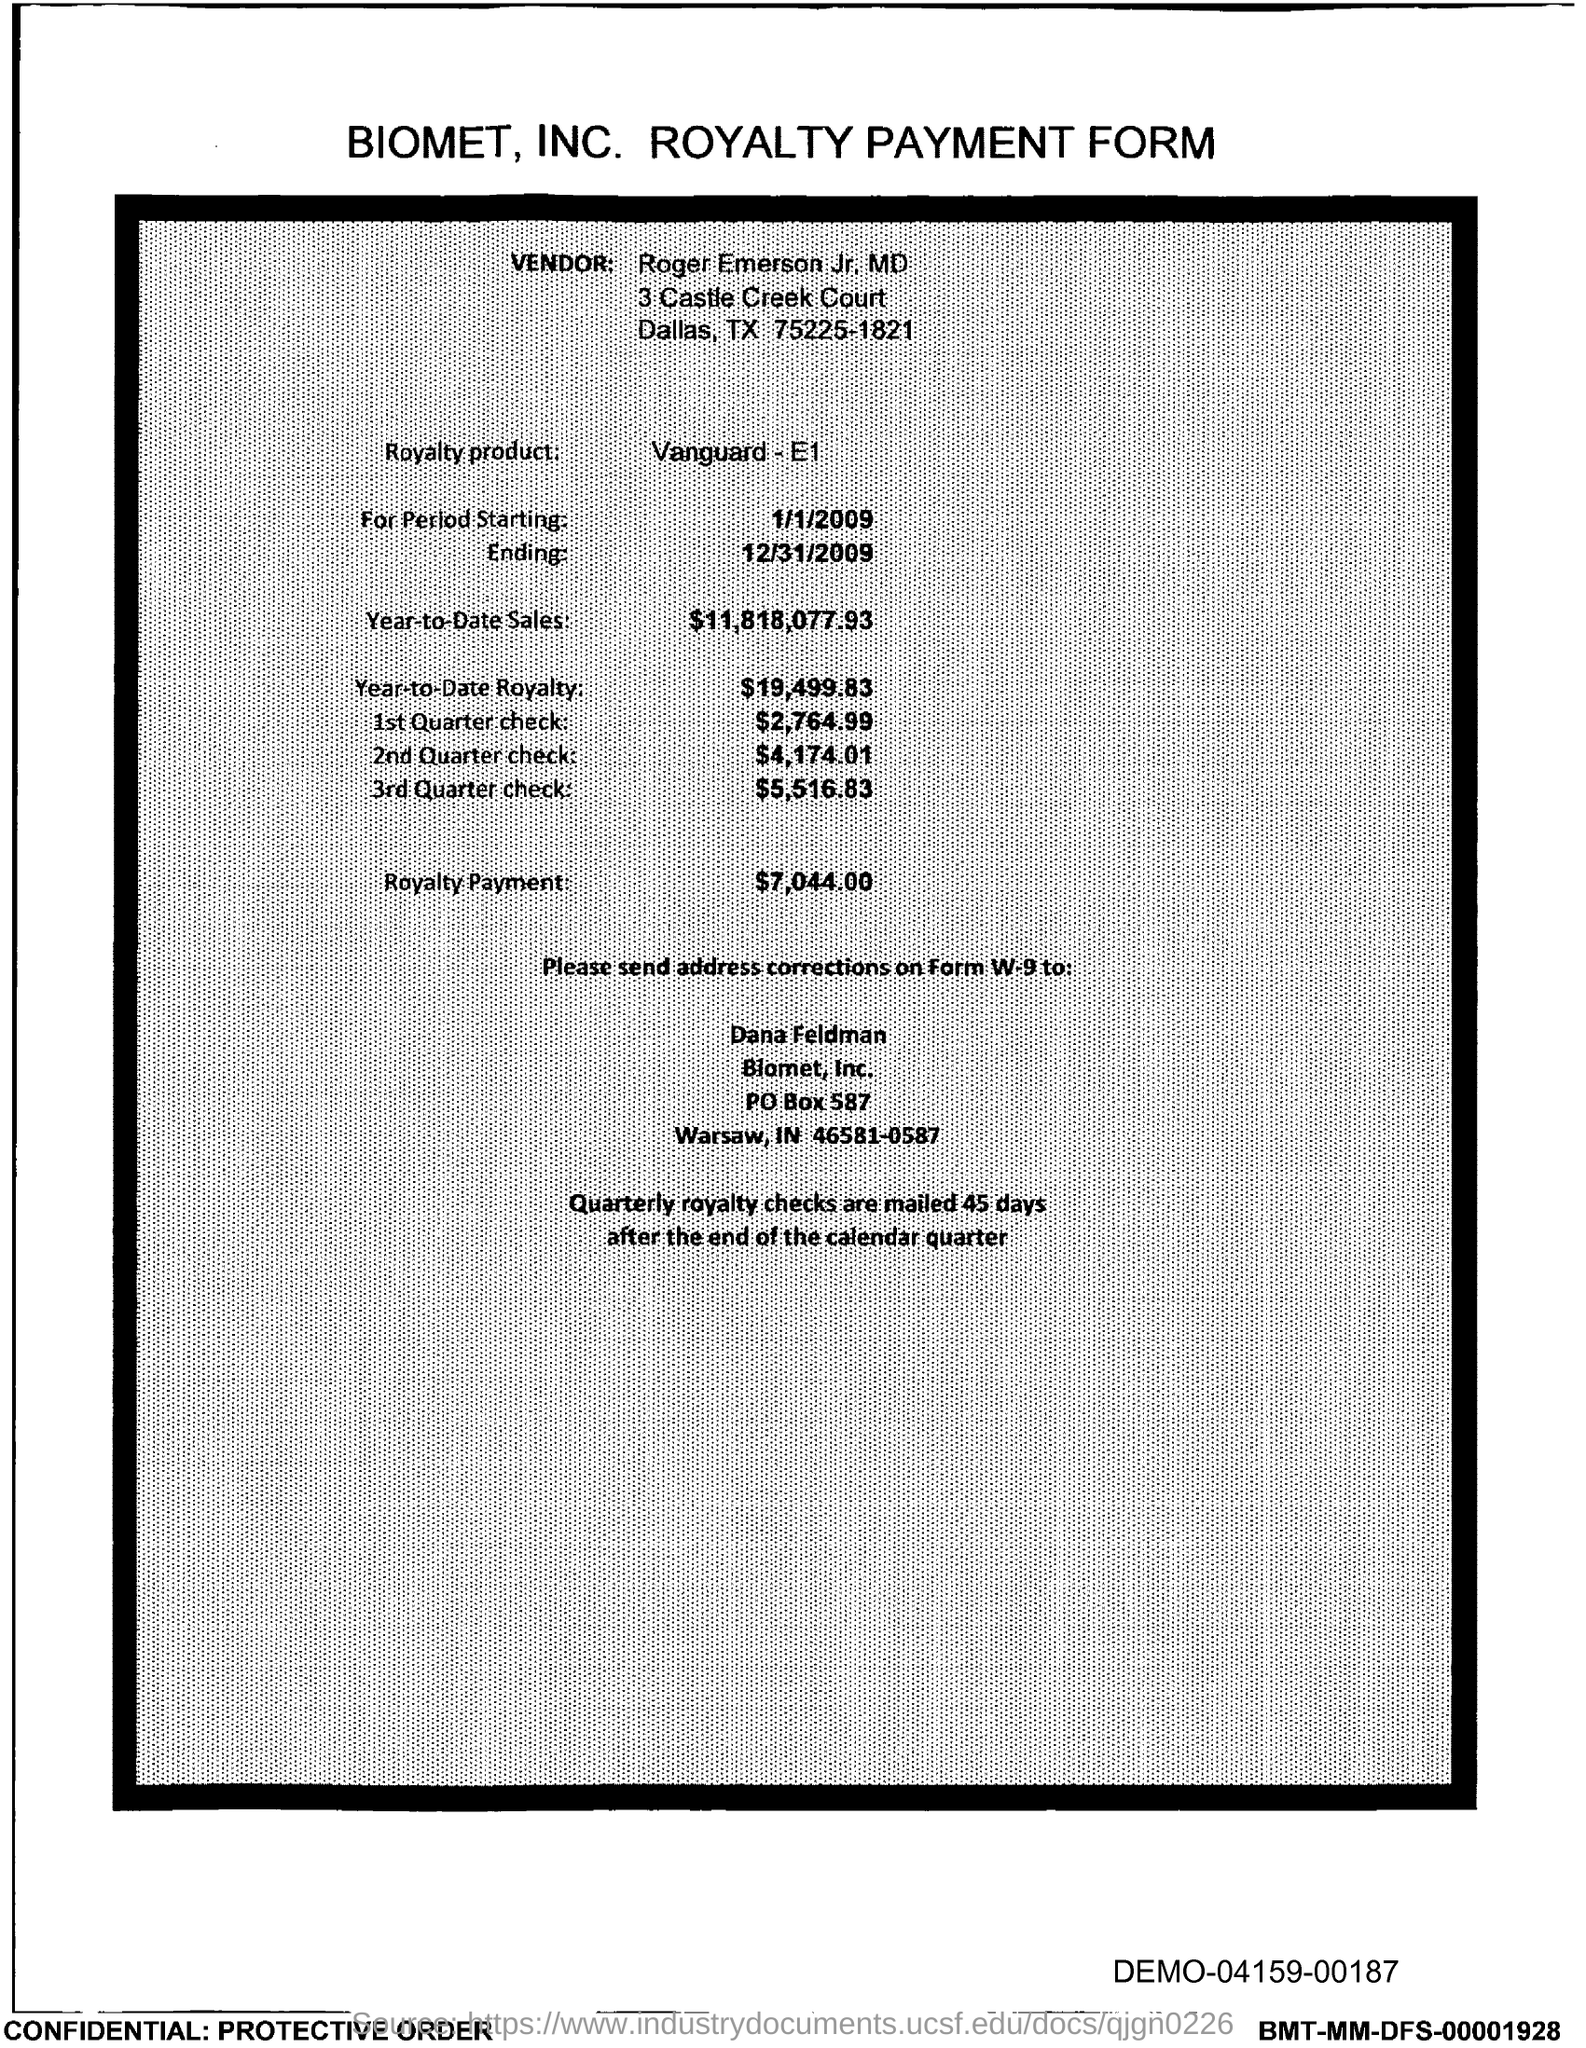Identify some key points in this picture. Biomet, Inc.'s PO box number is 587. Biomet, Inc. is located in the state of Indiana. The royalty product name is Vanguard-E1. The royalty payment is $7,044.00. Year-to-date sales as of January 1, 2023, have reached a total of $11,818,077.93. 